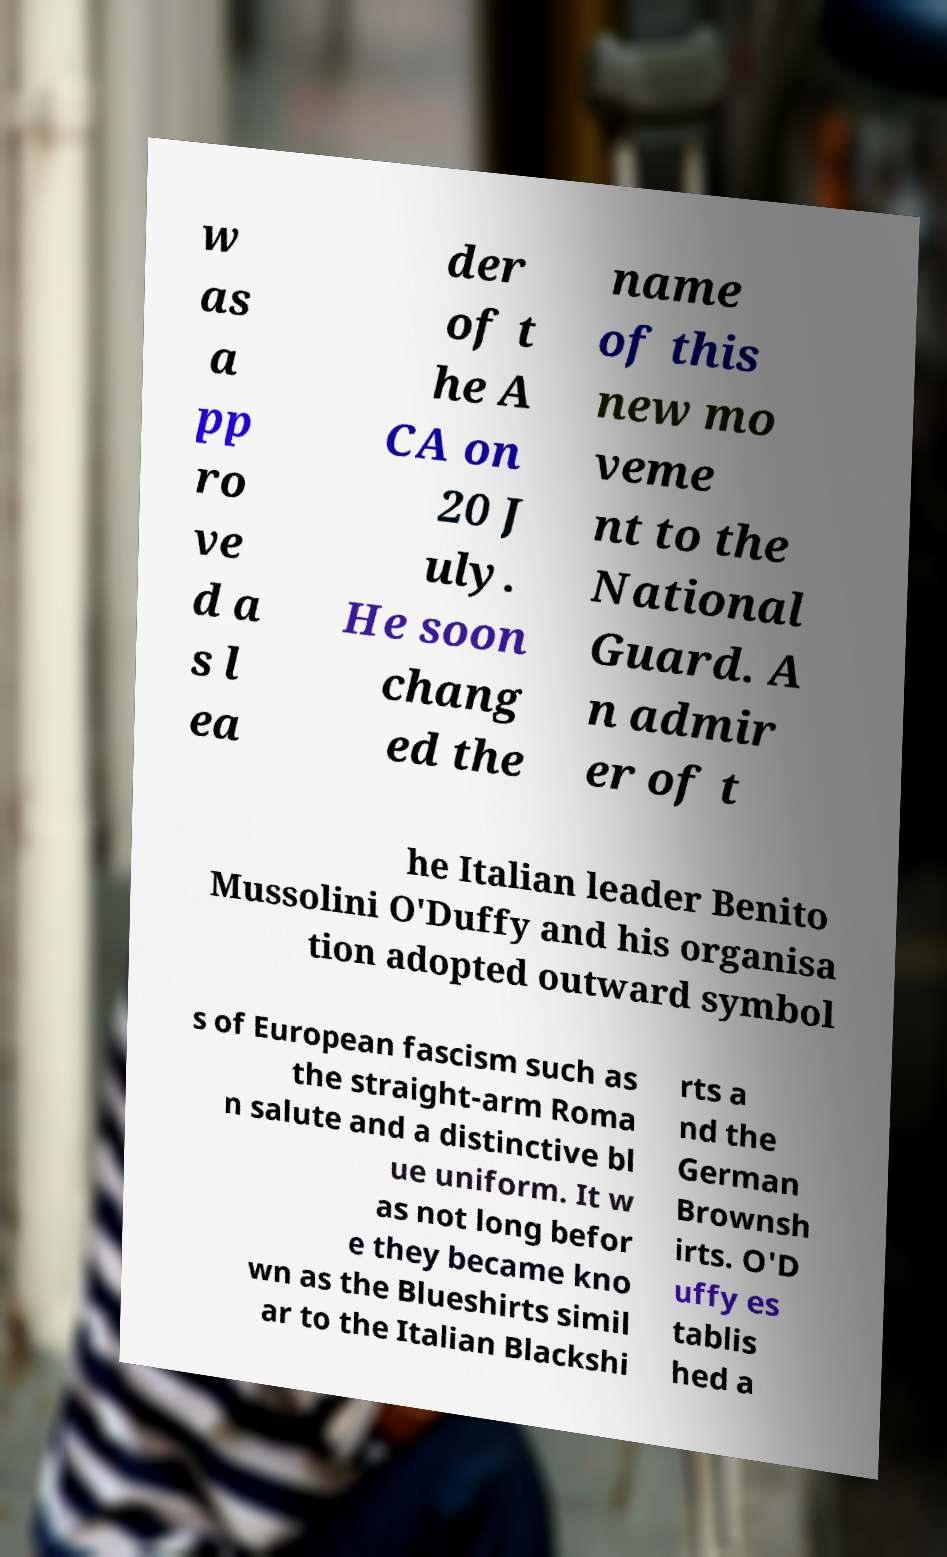Please identify and transcribe the text found in this image. w as a pp ro ve d a s l ea der of t he A CA on 20 J uly. He soon chang ed the name of this new mo veme nt to the National Guard. A n admir er of t he Italian leader Benito Mussolini O'Duffy and his organisa tion adopted outward symbol s of European fascism such as the straight-arm Roma n salute and a distinctive bl ue uniform. It w as not long befor e they became kno wn as the Blueshirts simil ar to the Italian Blackshi rts a nd the German Brownsh irts. O'D uffy es tablis hed a 